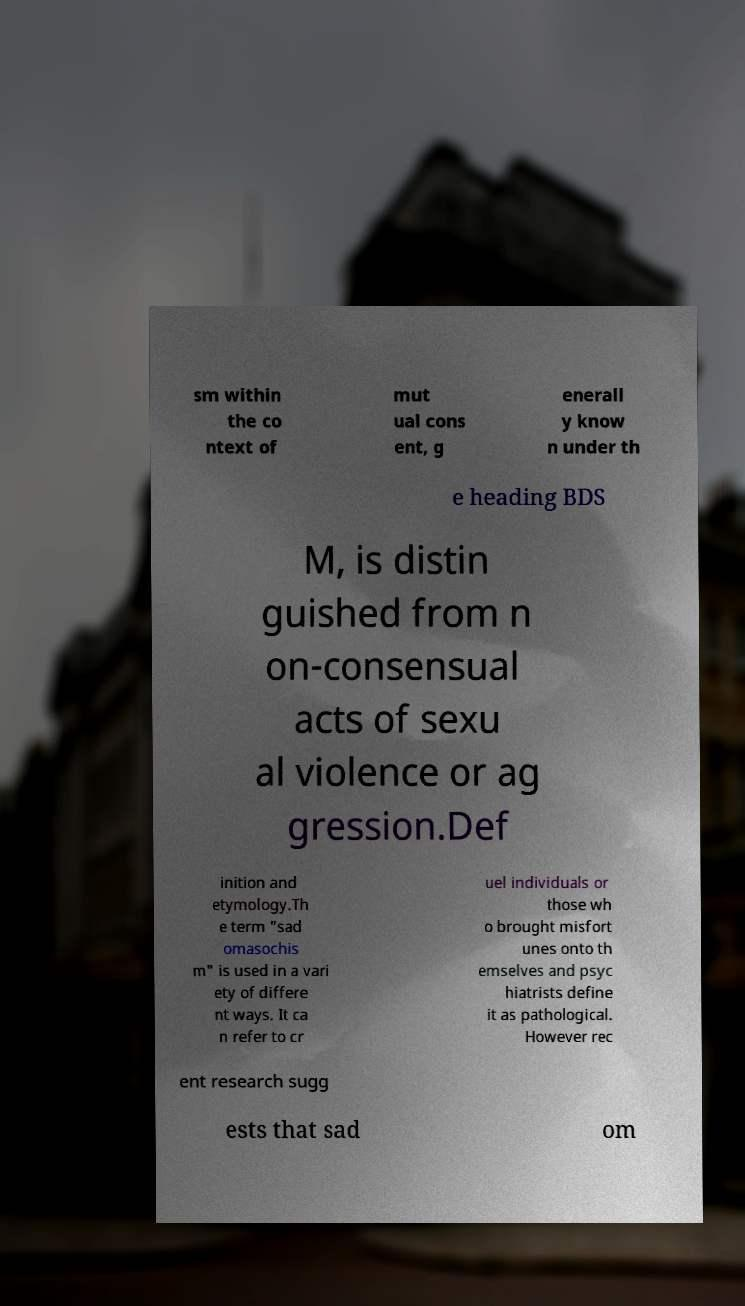Can you read and provide the text displayed in the image?This photo seems to have some interesting text. Can you extract and type it out for me? sm within the co ntext of mut ual cons ent, g enerall y know n under th e heading BDS M, is distin guished from n on-consensual acts of sexu al violence or ag gression.Def inition and etymology.Th e term "sad omasochis m" is used in a vari ety of differe nt ways. It ca n refer to cr uel individuals or those wh o brought misfort unes onto th emselves and psyc hiatrists define it as pathological. However rec ent research sugg ests that sad om 